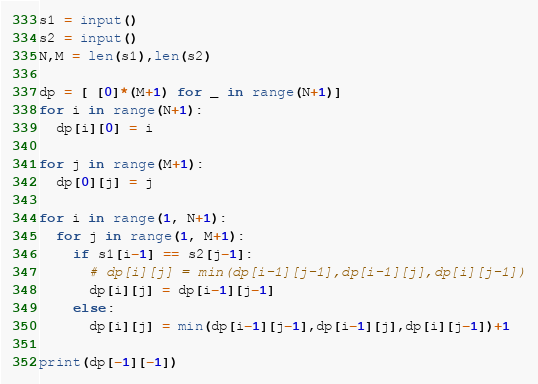<code> <loc_0><loc_0><loc_500><loc_500><_Python_>s1 = input()
s2 = input()
N,M = len(s1),len(s2)

dp = [ [0]*(M+1) for _ in range(N+1)]
for i in range(N+1):
  dp[i][0] = i

for j in range(M+1):
  dp[0][j] = j

for i in range(1, N+1):
  for j in range(1, M+1):
    if s1[i-1] == s2[j-1]:
      # dp[i][j] = min(dp[i-1][j-1],dp[i-1][j],dp[i][j-1])
      dp[i][j] = dp[i-1][j-1]
    else:
      dp[i][j] = min(dp[i-1][j-1],dp[i-1][j],dp[i][j-1])+1

print(dp[-1][-1])
</code> 